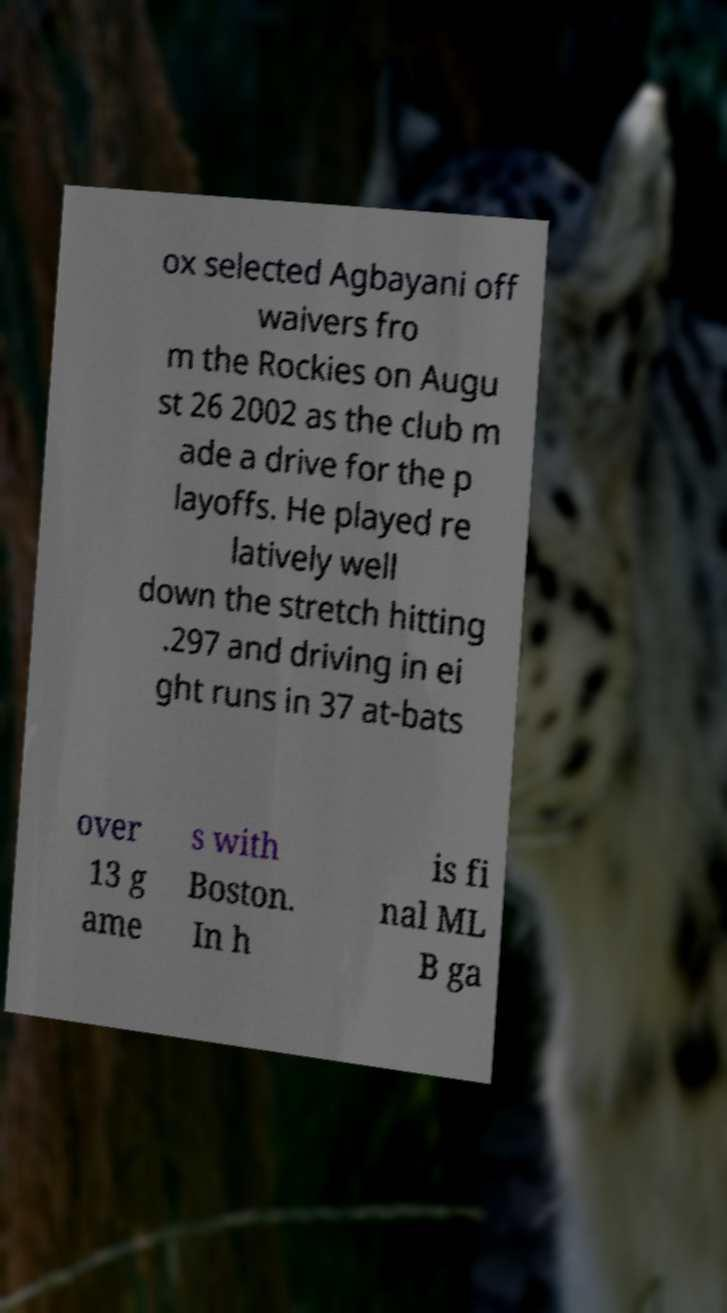What messages or text are displayed in this image? I need them in a readable, typed format. ox selected Agbayani off waivers fro m the Rockies on Augu st 26 2002 as the club m ade a drive for the p layoffs. He played re latively well down the stretch hitting .297 and driving in ei ght runs in 37 at-bats over 13 g ame s with Boston. In h is fi nal ML B ga 